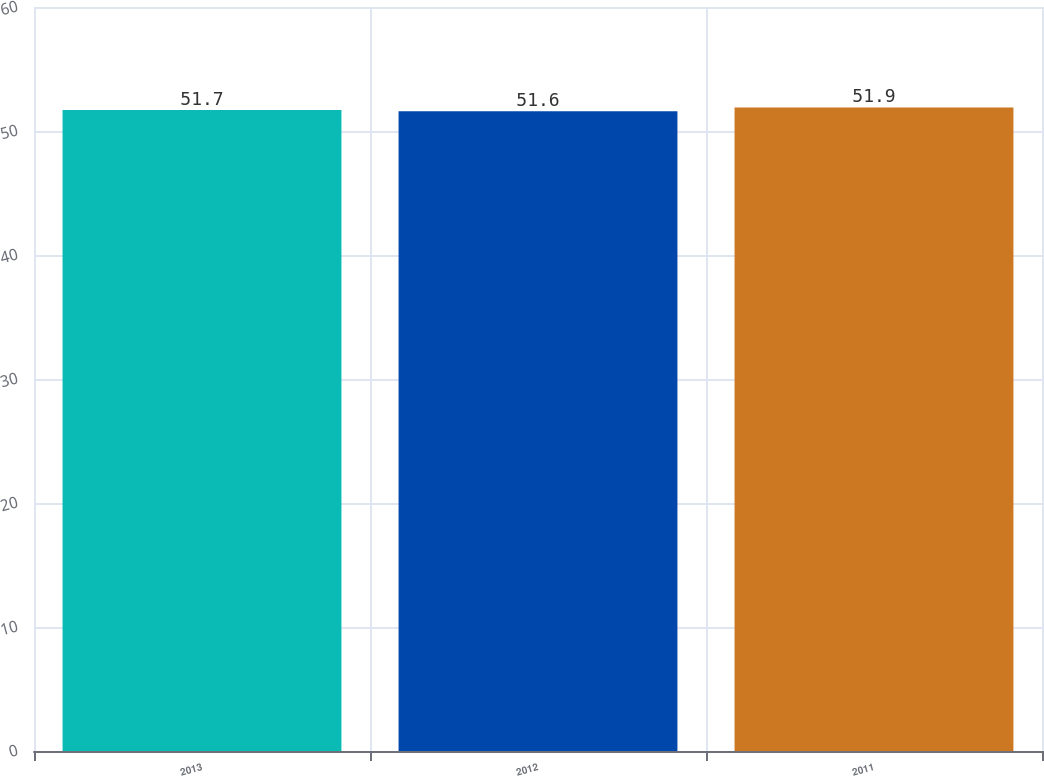Convert chart. <chart><loc_0><loc_0><loc_500><loc_500><bar_chart><fcel>2013<fcel>2012<fcel>2011<nl><fcel>51.7<fcel>51.6<fcel>51.9<nl></chart> 